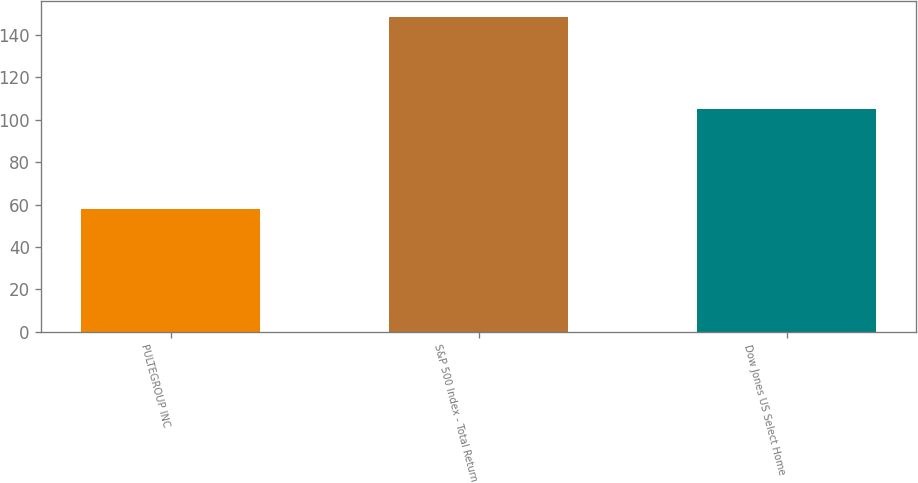<chart> <loc_0><loc_0><loc_500><loc_500><bar_chart><fcel>PULTEGROUP INC<fcel>S&P 500 Index - Total Return<fcel>Dow Jones US Select Home<nl><fcel>57.73<fcel>148.59<fcel>104.9<nl></chart> 